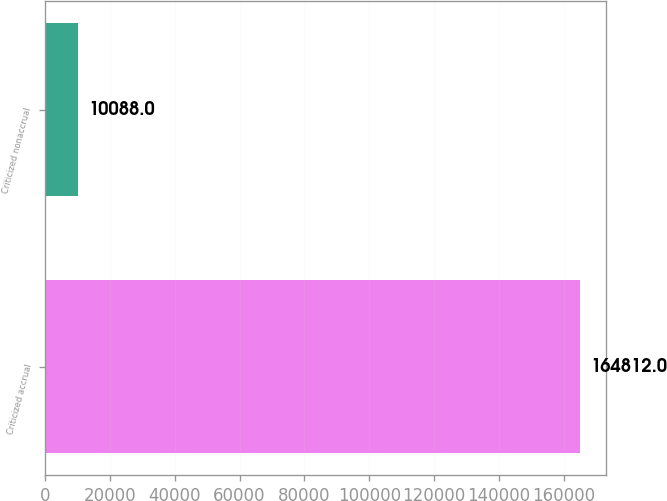Convert chart. <chart><loc_0><loc_0><loc_500><loc_500><bar_chart><fcel>Criticized accrual<fcel>Criticized nonaccrual<nl><fcel>164812<fcel>10088<nl></chart> 